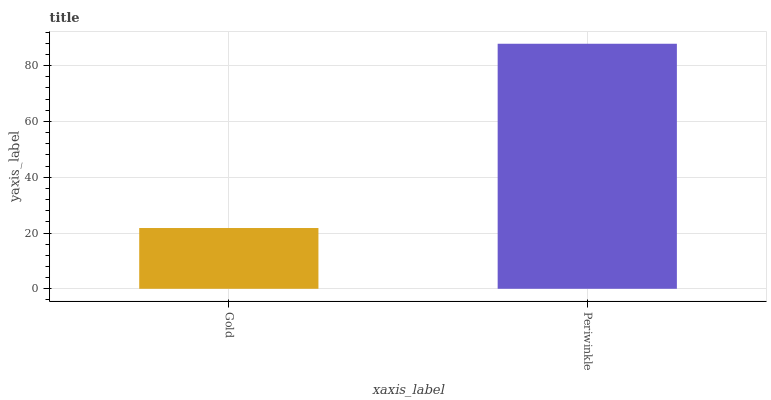Is Gold the minimum?
Answer yes or no. Yes. Is Periwinkle the maximum?
Answer yes or no. Yes. Is Periwinkle the minimum?
Answer yes or no. No. Is Periwinkle greater than Gold?
Answer yes or no. Yes. Is Gold less than Periwinkle?
Answer yes or no. Yes. Is Gold greater than Periwinkle?
Answer yes or no. No. Is Periwinkle less than Gold?
Answer yes or no. No. Is Periwinkle the high median?
Answer yes or no. Yes. Is Gold the low median?
Answer yes or no. Yes. Is Gold the high median?
Answer yes or no. No. Is Periwinkle the low median?
Answer yes or no. No. 